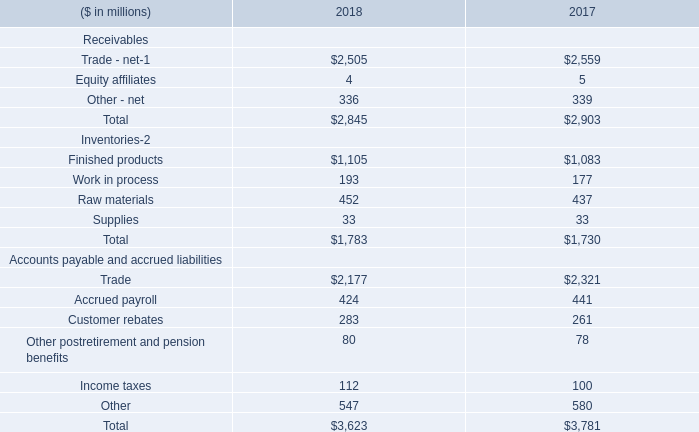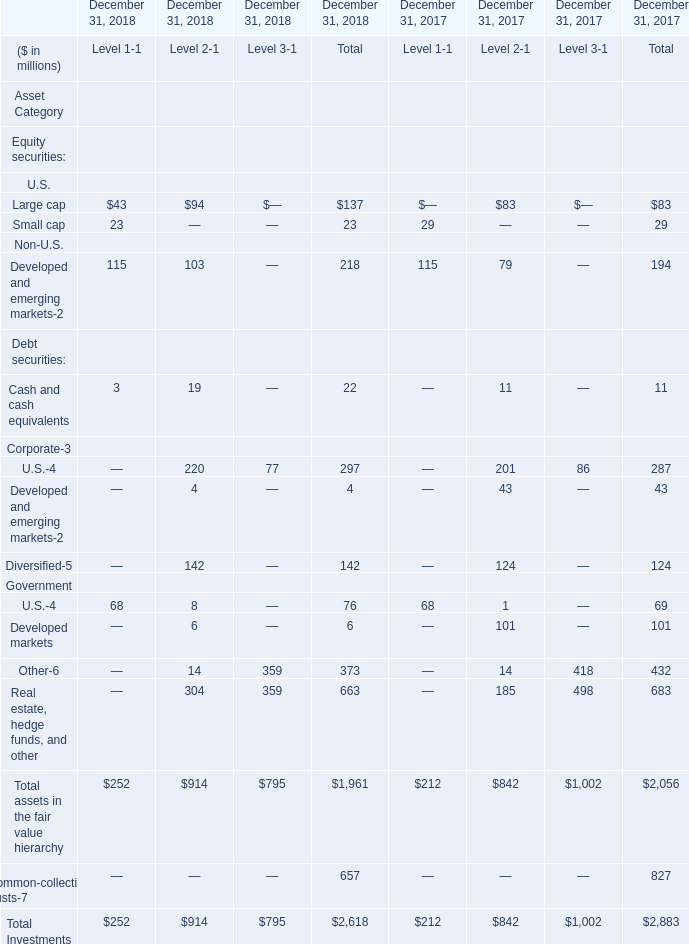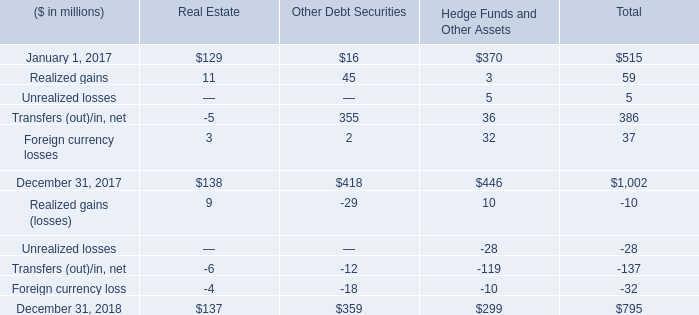In the section with the most Realized gains, what is the growth rate of Transfers (out)/in, net? 
Computations: ((355 - -5) / 355)
Answer: 1.01408. 